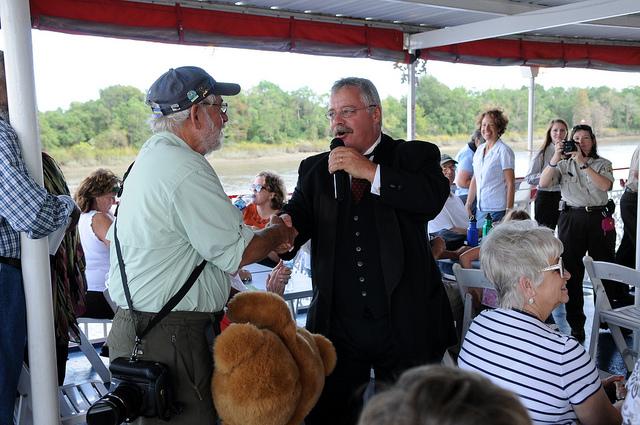What does the man in green have on his head?
Be succinct. Hat. What color is the striped shirt?
Concise answer only. White. What is the man holding?
Concise answer only. Microphone. 